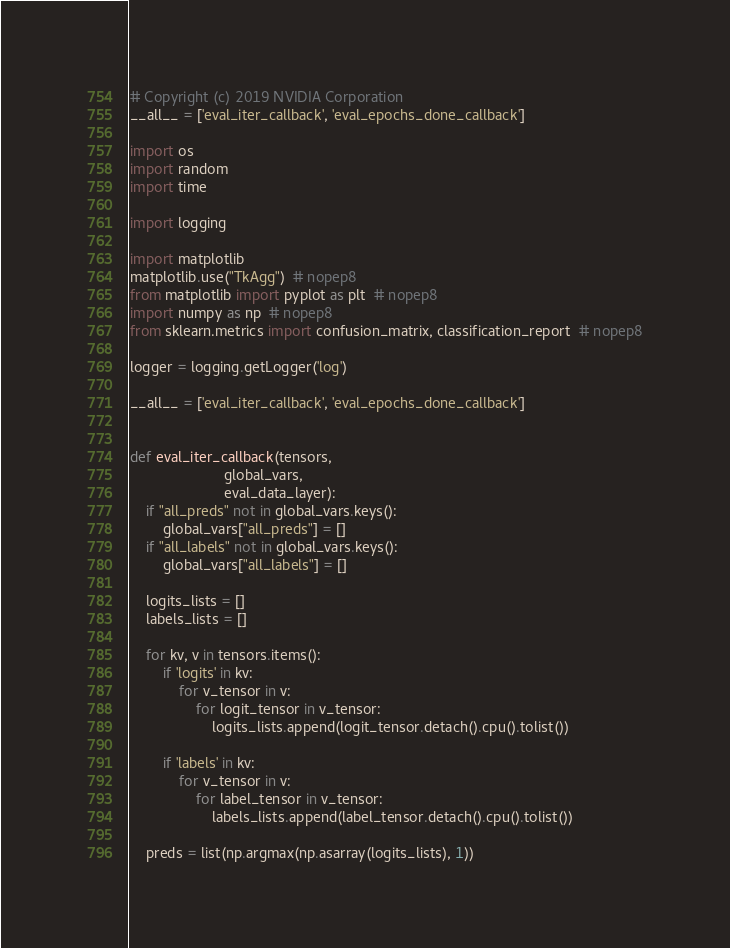Convert code to text. <code><loc_0><loc_0><loc_500><loc_500><_Python_># Copyright (c) 2019 NVIDIA Corporation
__all__ = ['eval_iter_callback', 'eval_epochs_done_callback']

import os
import random
import time

import logging

import matplotlib
matplotlib.use("TkAgg")  # nopep8
from matplotlib import pyplot as plt  # nopep8
import numpy as np  # nopep8
from sklearn.metrics import confusion_matrix, classification_report  # nopep8

logger = logging.getLogger('log')

__all__ = ['eval_iter_callback', 'eval_epochs_done_callback']


def eval_iter_callback(tensors,
                       global_vars,
                       eval_data_layer):
    if "all_preds" not in global_vars.keys():
        global_vars["all_preds"] = []
    if "all_labels" not in global_vars.keys():
        global_vars["all_labels"] = []

    logits_lists = []
    labels_lists = []

    for kv, v in tensors.items():
        if 'logits' in kv:
            for v_tensor in v:
                for logit_tensor in v_tensor:
                    logits_lists.append(logit_tensor.detach().cpu().tolist())

        if 'labels' in kv:
            for v_tensor in v:
                for label_tensor in v_tensor:
                    labels_lists.append(label_tensor.detach().cpu().tolist())

    preds = list(np.argmax(np.asarray(logits_lists), 1))</code> 